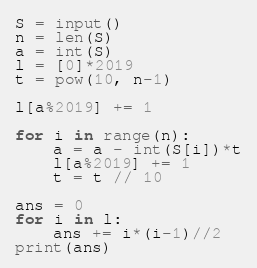<code> <loc_0><loc_0><loc_500><loc_500><_Python_>S = input()
n = len(S)
a = int(S)
l = [0]*2019
t = pow(10, n-1)

l[a%2019] += 1

for i in range(n):
    a = a - int(S[i])*t
    l[a%2019] += 1
    t = t // 10

ans = 0
for i in l:
    ans += i*(i-1)//2
print(ans)
</code> 